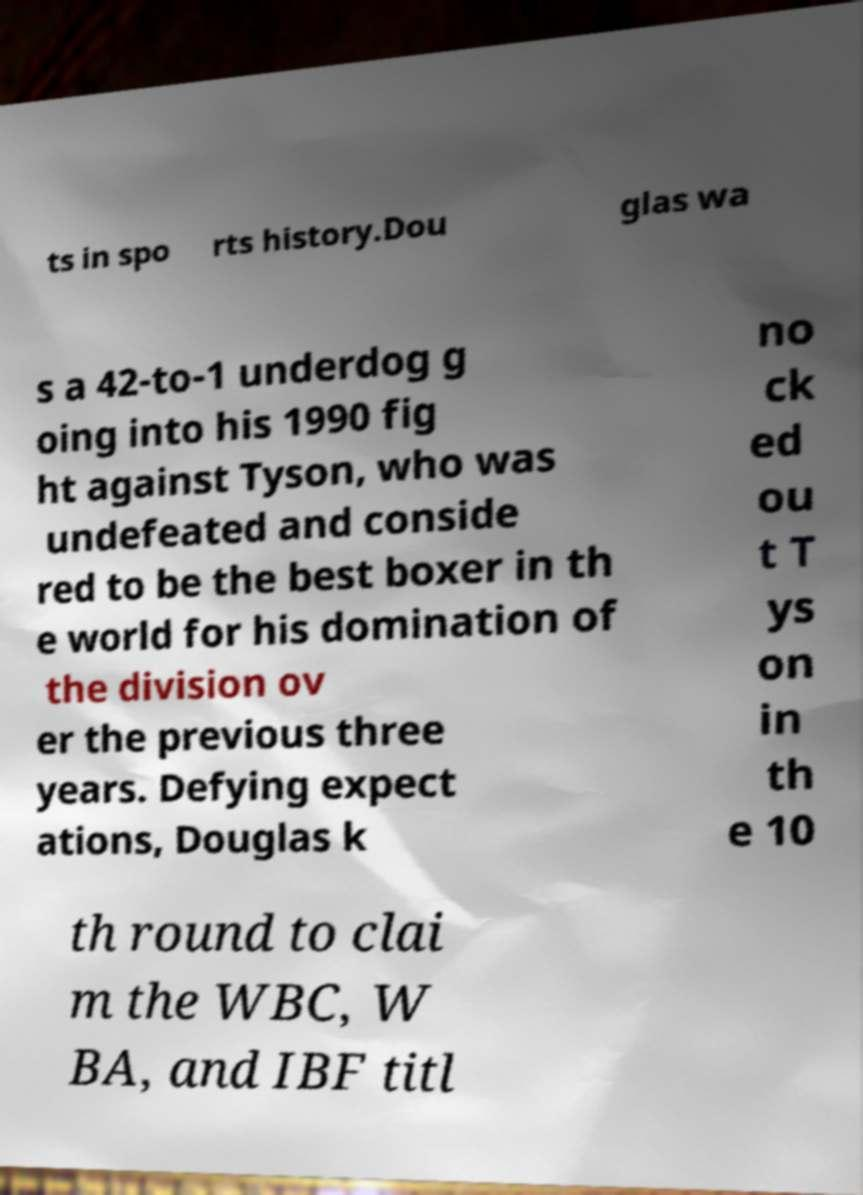What messages or text are displayed in this image? I need them in a readable, typed format. ts in spo rts history.Dou glas wa s a 42-to-1 underdog g oing into his 1990 fig ht against Tyson, who was undefeated and conside red to be the best boxer in th e world for his domination of the division ov er the previous three years. Defying expect ations, Douglas k no ck ed ou t T ys on in th e 10 th round to clai m the WBC, W BA, and IBF titl 